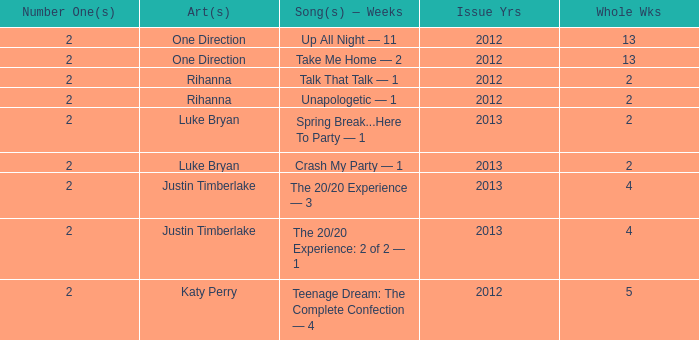What is the longest number of weeks any 1 song was at number #1? 13.0. 